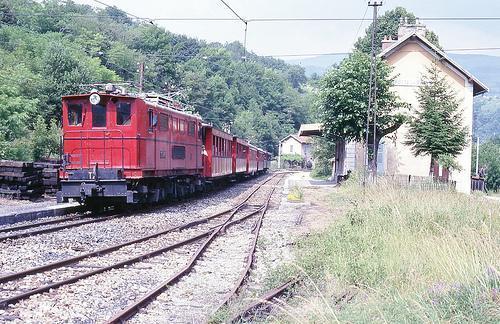How many trains on the tracks?
Give a very brief answer. 1. How many trees on the side of the beige house?
Give a very brief answer. 2. 